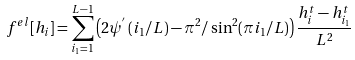Convert formula to latex. <formula><loc_0><loc_0><loc_500><loc_500>f ^ { e l } [ h _ { i } ] = \sum _ { i _ { 1 } = 1 } ^ { L - 1 } \left ( 2 { \psi } ^ { ^ { \prime } } \left ( i _ { 1 } / L \right ) - \pi ^ { 2 } / \sin ^ { 2 } ( \pi i _ { 1 } / L ) \right ) { \frac { h _ { i } ^ { t } - h _ { i _ { 1 } } ^ { t } } { L ^ { 2 } } }</formula> 